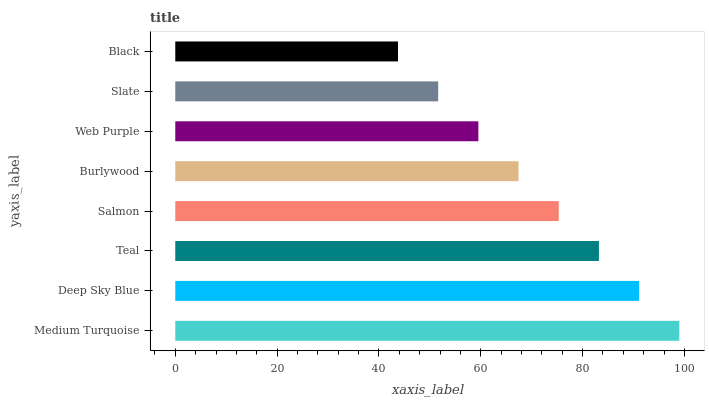Is Black the minimum?
Answer yes or no. Yes. Is Medium Turquoise the maximum?
Answer yes or no. Yes. Is Deep Sky Blue the minimum?
Answer yes or no. No. Is Deep Sky Blue the maximum?
Answer yes or no. No. Is Medium Turquoise greater than Deep Sky Blue?
Answer yes or no. Yes. Is Deep Sky Blue less than Medium Turquoise?
Answer yes or no. Yes. Is Deep Sky Blue greater than Medium Turquoise?
Answer yes or no. No. Is Medium Turquoise less than Deep Sky Blue?
Answer yes or no. No. Is Salmon the high median?
Answer yes or no. Yes. Is Burlywood the low median?
Answer yes or no. Yes. Is Web Purple the high median?
Answer yes or no. No. Is Slate the low median?
Answer yes or no. No. 